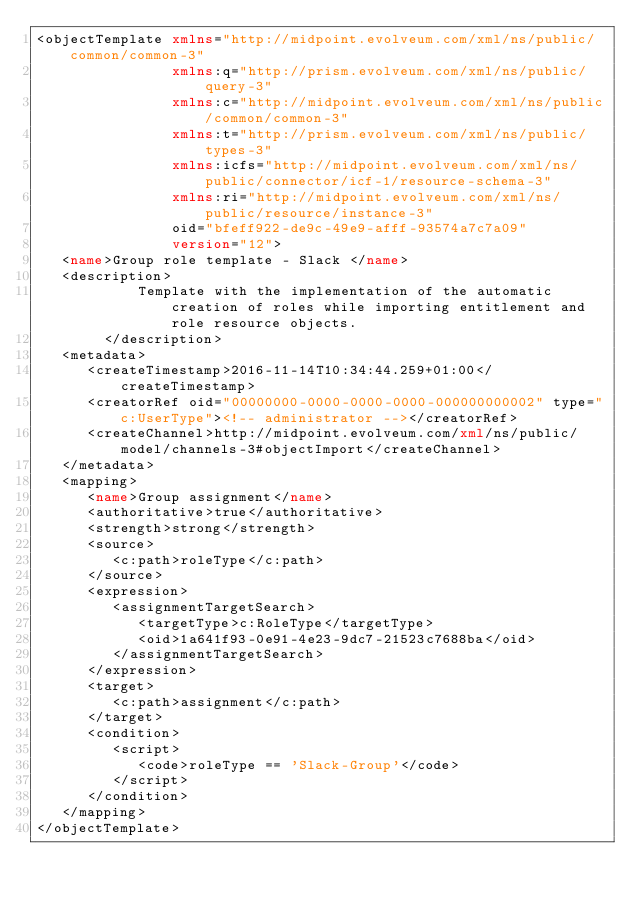<code> <loc_0><loc_0><loc_500><loc_500><_XML_><objectTemplate xmlns="http://midpoint.evolveum.com/xml/ns/public/common/common-3"
                xmlns:q="http://prism.evolveum.com/xml/ns/public/query-3"
                xmlns:c="http://midpoint.evolveum.com/xml/ns/public/common/common-3"
                xmlns:t="http://prism.evolveum.com/xml/ns/public/types-3"
                xmlns:icfs="http://midpoint.evolveum.com/xml/ns/public/connector/icf-1/resource-schema-3"
                xmlns:ri="http://midpoint.evolveum.com/xml/ns/public/resource/instance-3"
                oid="bfeff922-de9c-49e9-afff-93574a7c7a09"
                version="12">
   <name>Group role template - Slack </name>
   <description>
            Template with the implementation of the automatic creation of roles while importing entitlement and role resource objects.
        </description>
   <metadata>
      <createTimestamp>2016-11-14T10:34:44.259+01:00</createTimestamp>
      <creatorRef oid="00000000-0000-0000-0000-000000000002" type="c:UserType"><!-- administrator --></creatorRef>
      <createChannel>http://midpoint.evolveum.com/xml/ns/public/model/channels-3#objectImport</createChannel>
   </metadata>
   <mapping>
      <name>Group assignment</name>
      <authoritative>true</authoritative>
      <strength>strong</strength>
      <source>
         <c:path>roleType</c:path>
      </source>
      <expression>
         <assignmentTargetSearch>
            <targetType>c:RoleType</targetType>
            <oid>1a641f93-0e91-4e23-9dc7-21523c7688ba</oid>
         </assignmentTargetSearch>
      </expression>
      <target>
         <c:path>assignment</c:path>
      </target>
      <condition>
         <script>
            <code>roleType == 'Slack-Group'</code>
         </script>
      </condition>
   </mapping>
</objectTemplate></code> 